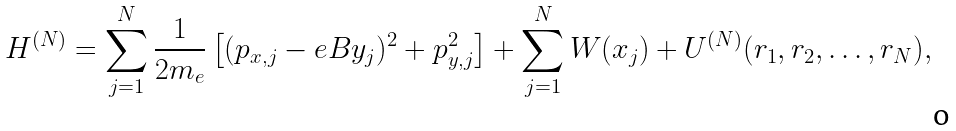<formula> <loc_0><loc_0><loc_500><loc_500>H ^ { ( N ) } = \sum _ { j = 1 } ^ { N } \frac { 1 } { 2 m _ { e } } \left [ ( p _ { x , j } - e B y _ { j } ) ^ { 2 } + p _ { y , j } ^ { 2 } \right ] + \sum _ { j = 1 } ^ { N } W ( x _ { j } ) + U ^ { ( N ) } ( { r } _ { 1 } , { r } _ { 2 } , \dots , { r } _ { N } ) ,</formula> 